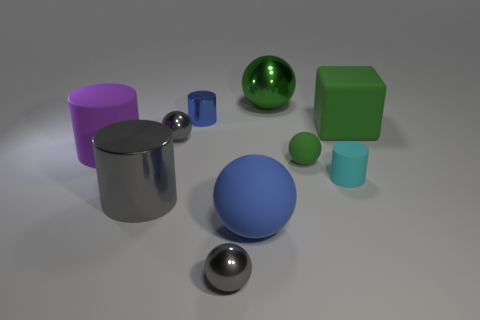How many big things are cyan rubber cylinders or gray things?
Provide a short and direct response. 1. Is the number of blue cylinders greater than the number of tiny yellow rubber objects?
Keep it short and to the point. Yes. What is the size of the blue sphere that is made of the same material as the purple object?
Provide a short and direct response. Large. Is the size of the rubber cylinder on the right side of the big gray cylinder the same as the blue object that is behind the tiny rubber ball?
Your answer should be compact. Yes. What number of things are either tiny gray spheres behind the large blue object or blue metallic objects?
Offer a very short reply. 2. Are there fewer big cyan things than large purple matte cylinders?
Provide a short and direct response. Yes. There is a big metallic thing in front of the rubber cylinder to the left of the gray ball that is in front of the small matte cylinder; what is its shape?
Ensure brevity in your answer.  Cylinder. The rubber object that is the same color as the tiny matte sphere is what shape?
Your answer should be very brief. Cube. Is there a ball?
Ensure brevity in your answer.  Yes. Does the purple matte object have the same size as the ball that is behind the big green cube?
Provide a succinct answer. Yes. 